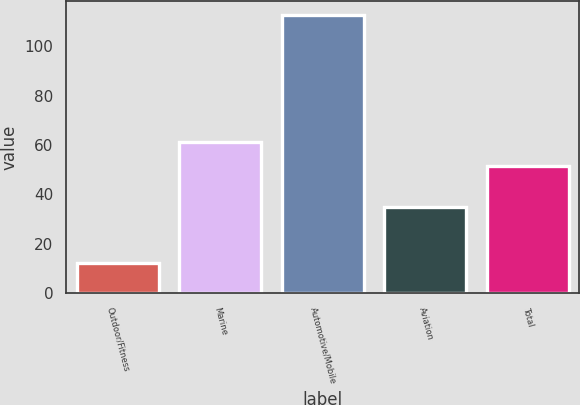Convert chart. <chart><loc_0><loc_0><loc_500><loc_500><bar_chart><fcel>Outdoor/Fitness<fcel>Marine<fcel>Automotive/Mobile<fcel>Aviation<fcel>Total<nl><fcel>12.3<fcel>61.33<fcel>112.6<fcel>34.8<fcel>51.3<nl></chart> 